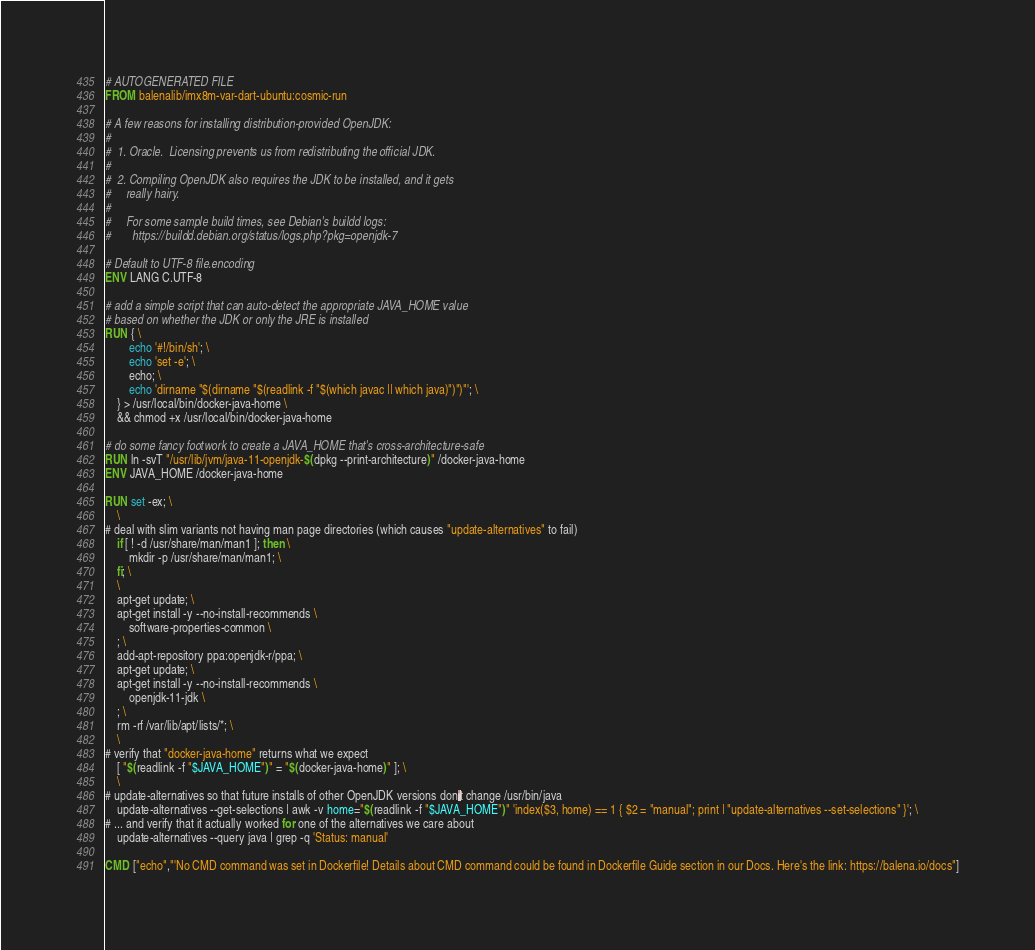<code> <loc_0><loc_0><loc_500><loc_500><_Dockerfile_># AUTOGENERATED FILE
FROM balenalib/imx8m-var-dart-ubuntu:cosmic-run

# A few reasons for installing distribution-provided OpenJDK:
#
#  1. Oracle.  Licensing prevents us from redistributing the official JDK.
#
#  2. Compiling OpenJDK also requires the JDK to be installed, and it gets
#     really hairy.
#
#     For some sample build times, see Debian's buildd logs:
#       https://buildd.debian.org/status/logs.php?pkg=openjdk-7

# Default to UTF-8 file.encoding
ENV LANG C.UTF-8

# add a simple script that can auto-detect the appropriate JAVA_HOME value
# based on whether the JDK or only the JRE is installed
RUN { \
		echo '#!/bin/sh'; \
		echo 'set -e'; \
		echo; \
		echo 'dirname "$(dirname "$(readlink -f "$(which javac || which java)")")"'; \
	} > /usr/local/bin/docker-java-home \
	&& chmod +x /usr/local/bin/docker-java-home

# do some fancy footwork to create a JAVA_HOME that's cross-architecture-safe
RUN ln -svT "/usr/lib/jvm/java-11-openjdk-$(dpkg --print-architecture)" /docker-java-home
ENV JAVA_HOME /docker-java-home

RUN set -ex; \
	\
# deal with slim variants not having man page directories (which causes "update-alternatives" to fail)
	if [ ! -d /usr/share/man/man1 ]; then \
		mkdir -p /usr/share/man/man1; \
	fi; \
	\
	apt-get update; \
	apt-get install -y --no-install-recommends \
		software-properties-common \
	; \
	add-apt-repository ppa:openjdk-r/ppa; \
	apt-get update; \
	apt-get install -y --no-install-recommends \
		openjdk-11-jdk \
	; \
	rm -rf /var/lib/apt/lists/*; \
	\
# verify that "docker-java-home" returns what we expect
	[ "$(readlink -f "$JAVA_HOME")" = "$(docker-java-home)" ]; \
	\
# update-alternatives so that future installs of other OpenJDK versions don't change /usr/bin/java
	update-alternatives --get-selections | awk -v home="$(readlink -f "$JAVA_HOME")" 'index($3, home) == 1 { $2 = "manual"; print | "update-alternatives --set-selections" }'; \
# ... and verify that it actually worked for one of the alternatives we care about
	update-alternatives --query java | grep -q 'Status: manual'

CMD ["echo","'No CMD command was set in Dockerfile! Details about CMD command could be found in Dockerfile Guide section in our Docs. Here's the link: https://balena.io/docs"]</code> 